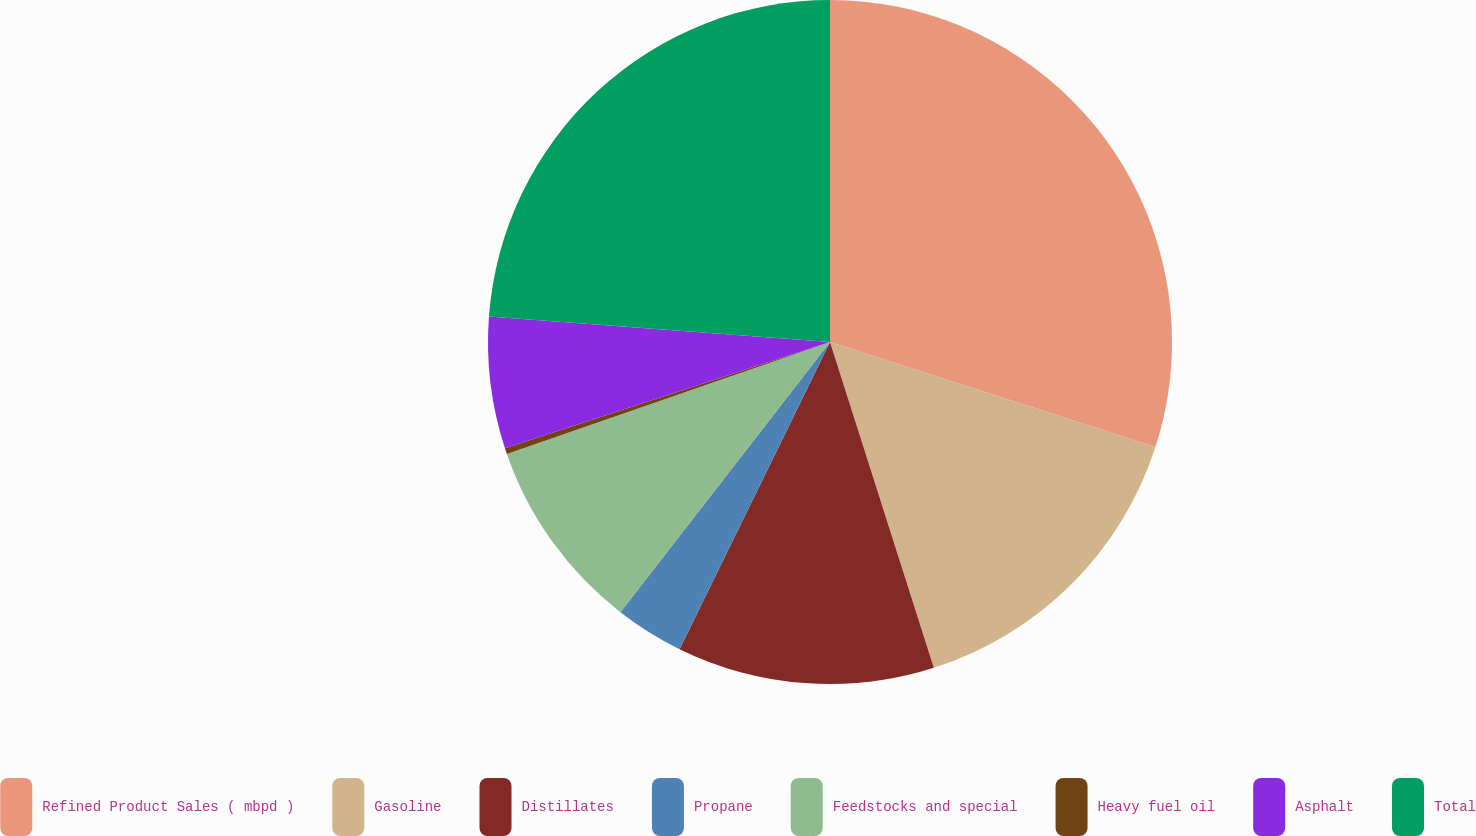<chart> <loc_0><loc_0><loc_500><loc_500><pie_chart><fcel>Refined Product Sales ( mbpd )<fcel>Gasoline<fcel>Distillates<fcel>Propane<fcel>Feedstocks and special<fcel>Heavy fuel oil<fcel>Asphalt<fcel>Total<nl><fcel>29.97%<fcel>15.12%<fcel>12.16%<fcel>3.25%<fcel>9.19%<fcel>0.28%<fcel>6.22%<fcel>23.81%<nl></chart> 